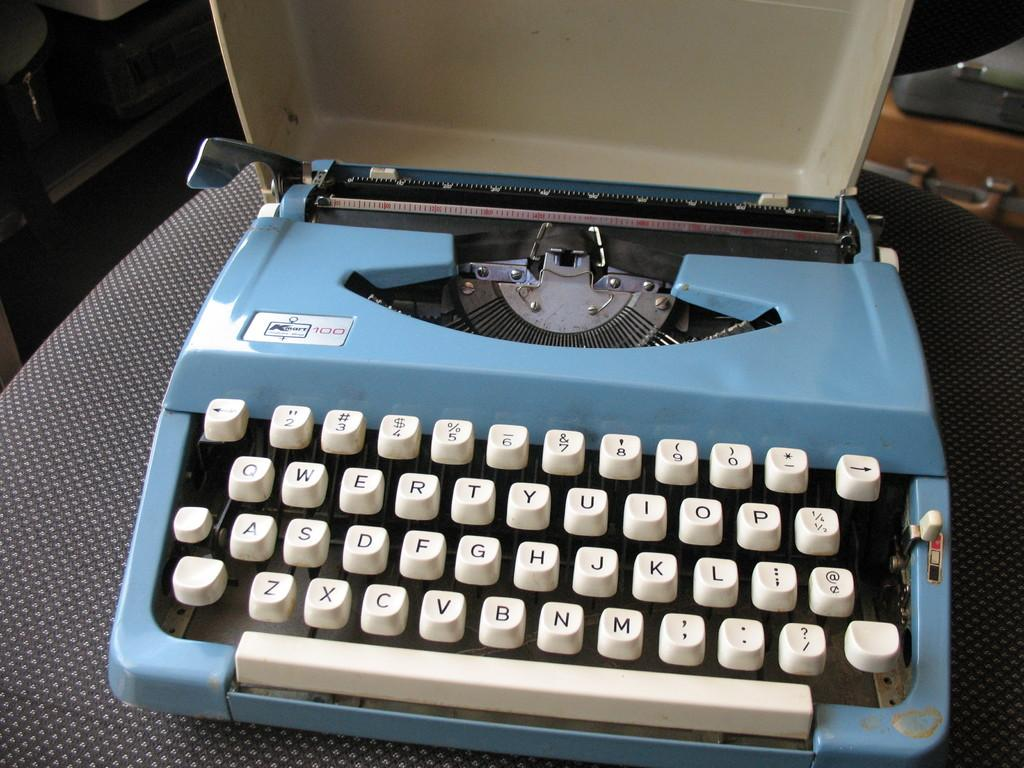<image>
Offer a succinct explanation of the picture presented. A blue typewriter with white keys such as the letters Z, X and C. 